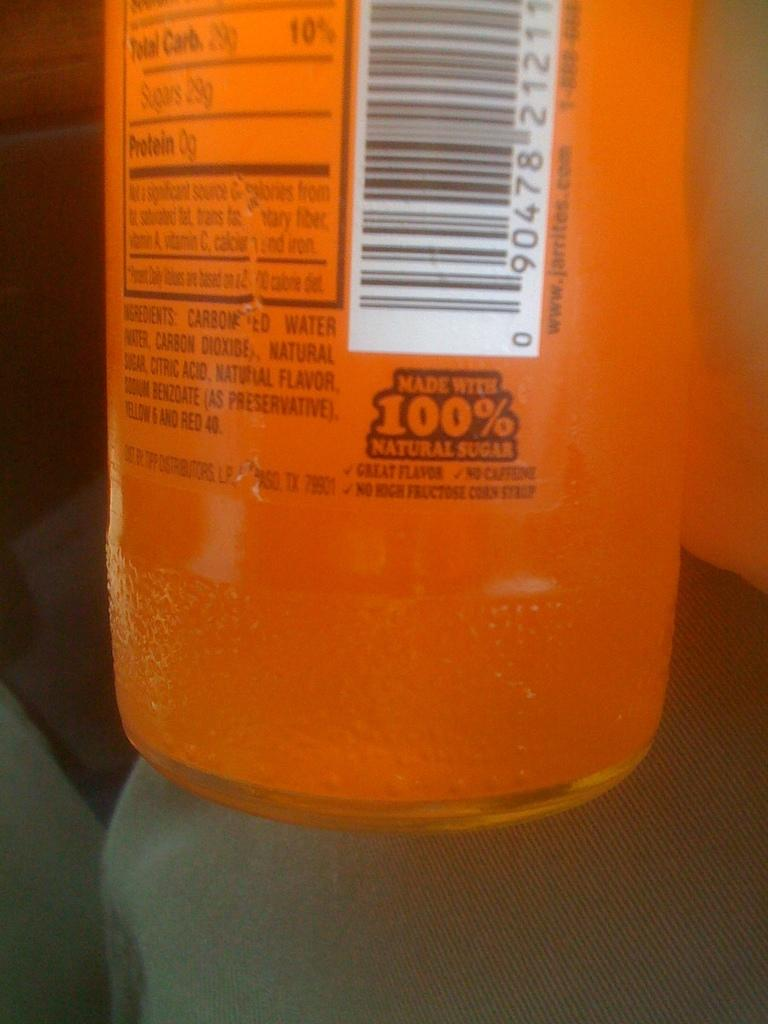Provide a one-sentence caption for the provided image. An orange bottle with the ingredients listed on the back. 